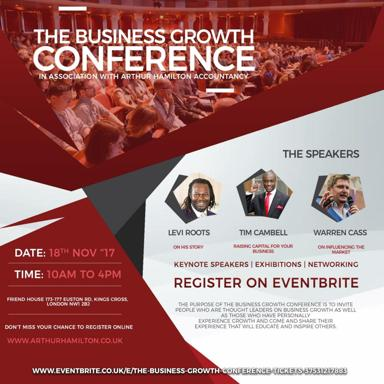What event is being advertised in the image? The event being advertised is The Business Growth Conference, offering opportunities for networking, keynotes, and exhibitions, all aimed at catalyzing business advancement. 